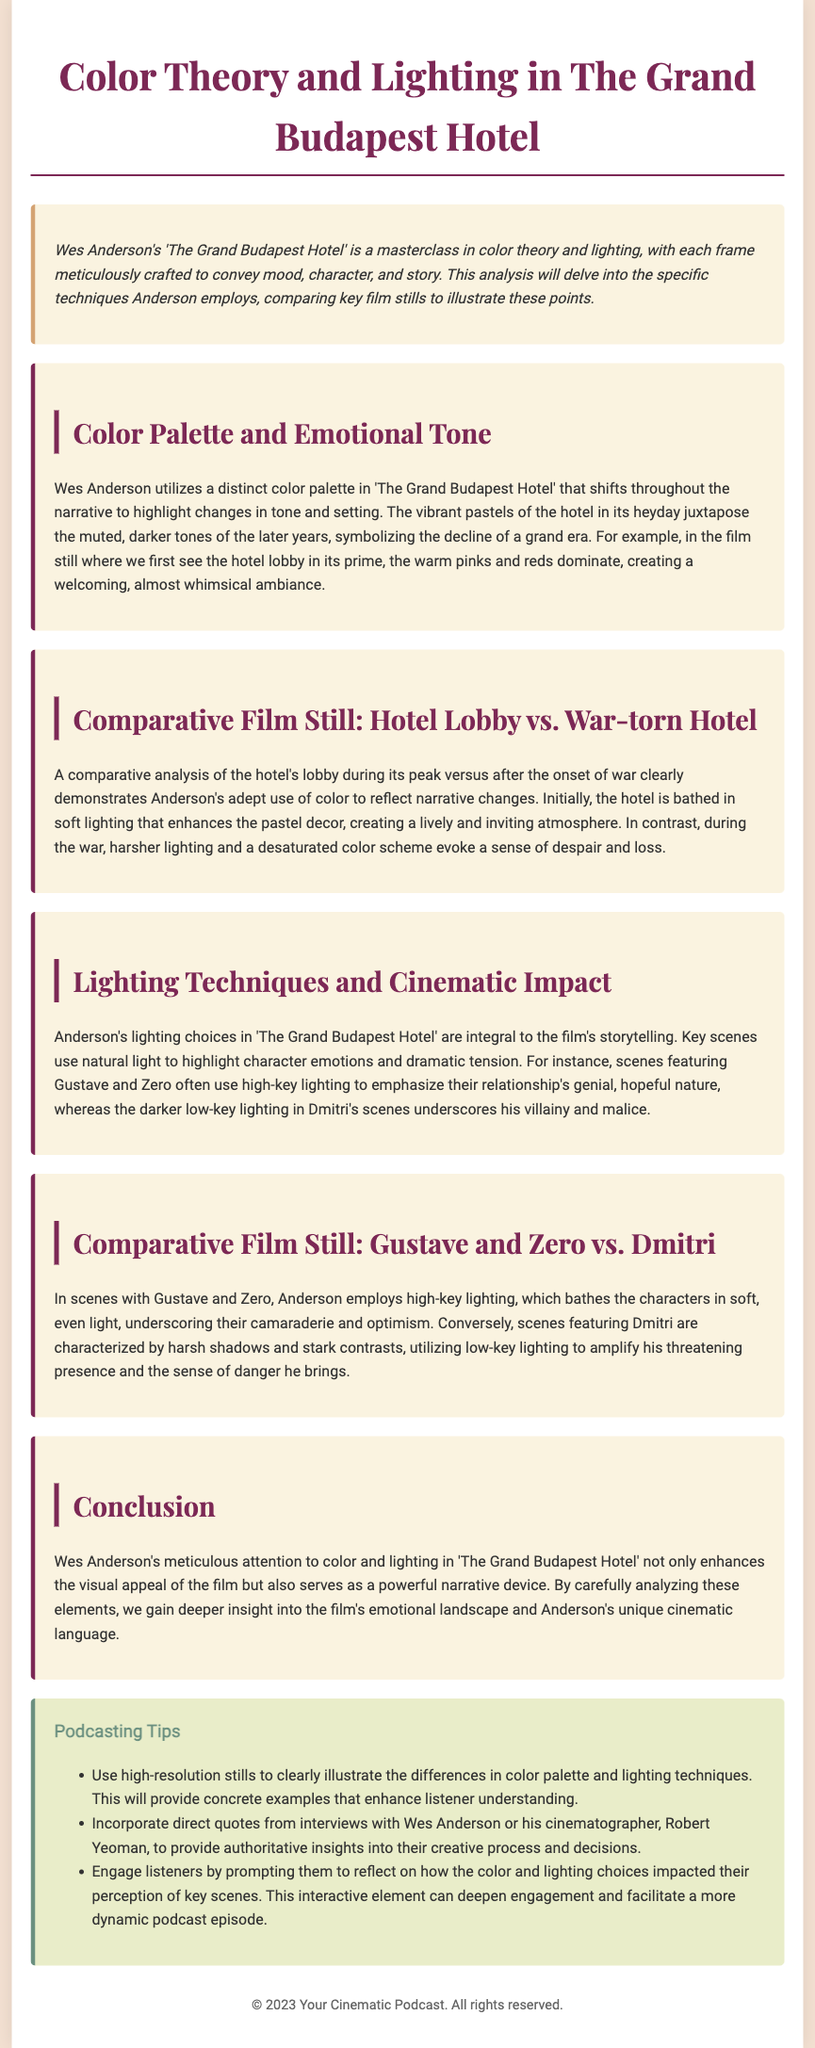What is the title of the film analyzed in the document? The document is centered around Wes Anderson's notable film, "The Grand Budapest Hotel."
Answer: "The Grand Budapest Hotel" What color palette is primarily used in the hotel's heyday? The introduction highlights warm pinks and reds as the dominant colors of the hotel lobby during its prime.
Answer: Warm pinks and reds What lighting technique is used to represent Gustave and Zero's relationship? The document states that high-key lighting emphasizes their camaraderie and optimistic relationship.
Answer: High-key lighting What is the effect of low-key lighting in Dmitri's scenes? Low-key lighting is described as amplifying Dmitri's threatening presence and sense of danger.
Answer: Amplifies threatening presence How does the color scheme shift throughout the narrative? The document explains that the vibrant pastels of the hotel contrast with the muted, darker tones of later years.
Answer: From vibrant pastels to muted, darker tones What technique does Anderson employ to enhance the emotional tone of the film? Wes Anderson's meticulous attention to color and lighting serves as a powerful narrative device.
Answer: Attention to color and lighting What is the suggested action to engage podcast listeners? One suggestion is to prompt listeners to reflect on the impact of color and lighting choices in key scenes.
Answer: Reflect on impact of color and lighting choices In which sections are comparative film stills discussed? The sections discussing comparative stills focus on the hotel lobby and Gustave and Zero versus Dmitri.
Answer: Hotel lobby vs. War-torn Hotel; Gustave and Zero vs. Dmitri 